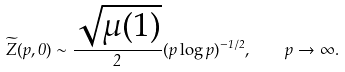<formula> <loc_0><loc_0><loc_500><loc_500>\widetilde { Z } ( p , 0 ) \sim \frac { \sqrt { \mu ( 1 ) } } 2 ( p \log p ) ^ { - 1 / 2 } , \quad p \to \infty .</formula> 